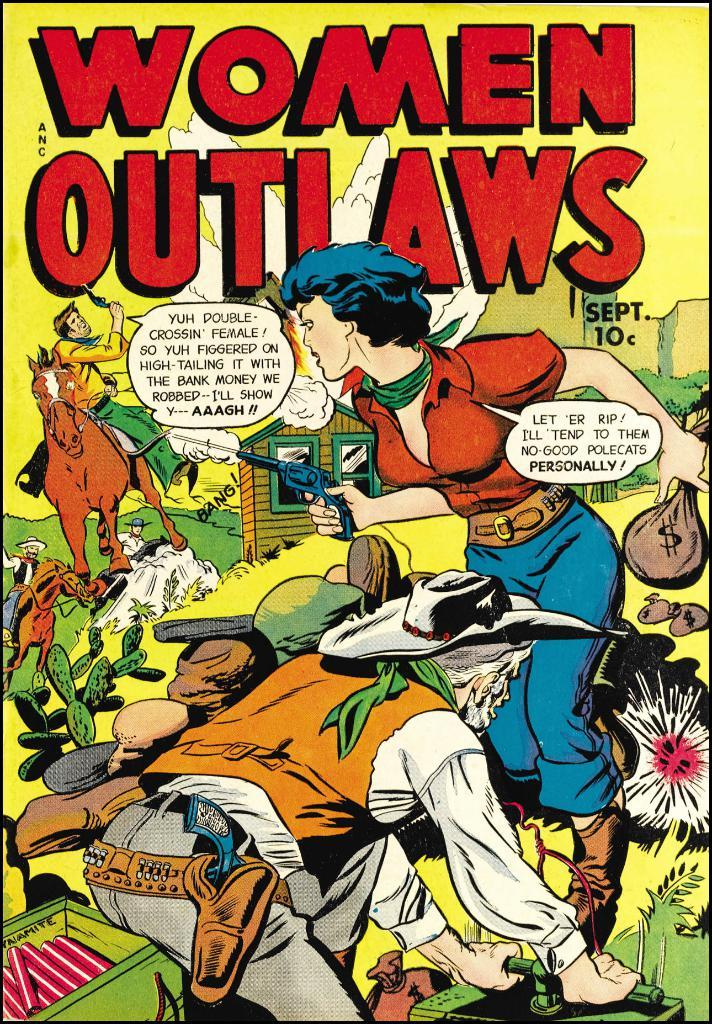<image>
Provide a brief description of the given image. A comic called Women Outlaws had a Sept. issue that only cost 10 cents. 